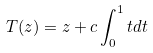<formula> <loc_0><loc_0><loc_500><loc_500>T ( z ) = z + c \int _ { 0 } ^ { 1 } t d t</formula> 